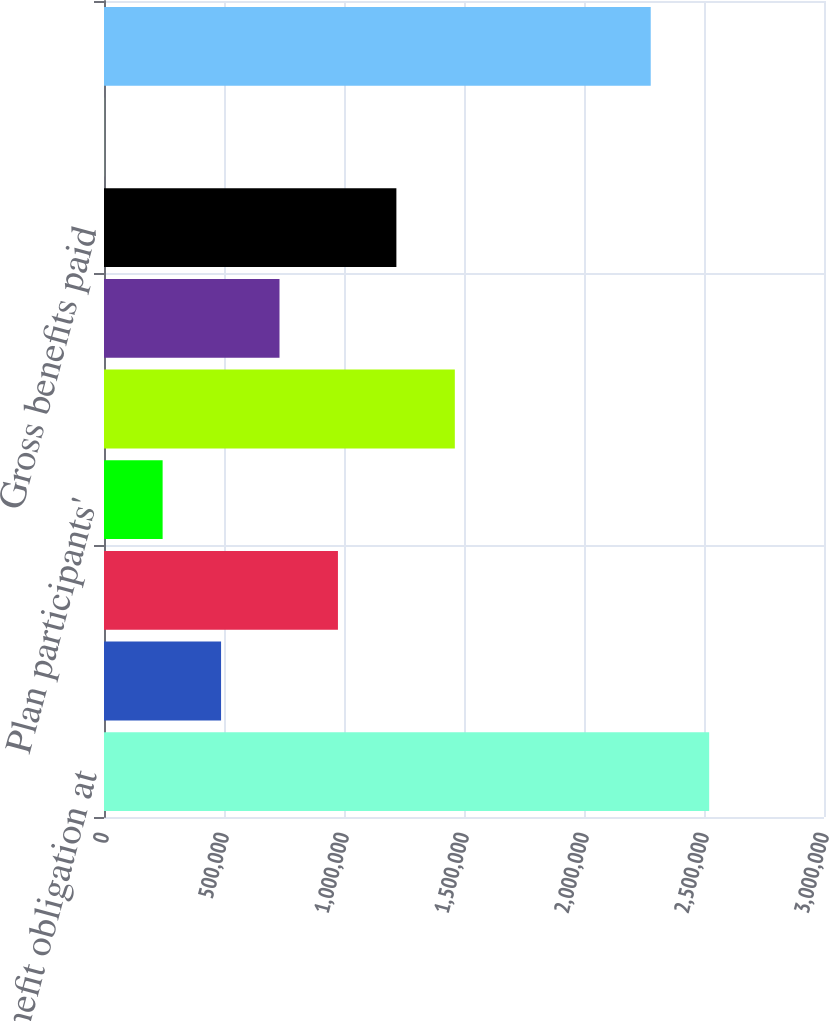<chart> <loc_0><loc_0><loc_500><loc_500><bar_chart><fcel>Benefit obligation at<fcel>Service cost<fcel>Interest cost<fcel>Plan participants'<fcel>Actuarial (gain) loss<fcel>Foreign currency exchange rate<fcel>Gross benefits paid<fcel>Acquired plans<fcel>Benefit obligation at end of<nl><fcel>2.52154e+06<fcel>487769<fcel>974768<fcel>244270<fcel>1.46177e+06<fcel>731268<fcel>1.21827e+06<fcel>770<fcel>2.27804e+06<nl></chart> 